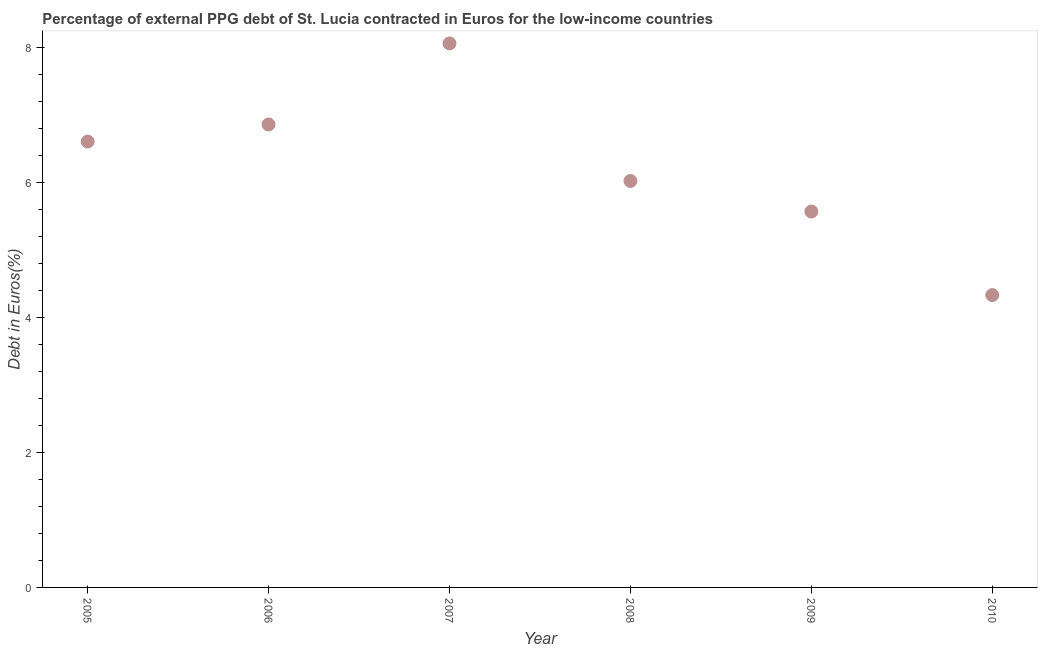What is the currency composition of ppg debt in 2006?
Offer a very short reply. 6.86. Across all years, what is the maximum currency composition of ppg debt?
Provide a short and direct response. 8.07. Across all years, what is the minimum currency composition of ppg debt?
Give a very brief answer. 4.33. What is the sum of the currency composition of ppg debt?
Provide a succinct answer. 37.48. What is the difference between the currency composition of ppg debt in 2005 and 2006?
Offer a terse response. -0.25. What is the average currency composition of ppg debt per year?
Your response must be concise. 6.25. What is the median currency composition of ppg debt?
Make the answer very short. 6.32. In how many years, is the currency composition of ppg debt greater than 2.8 %?
Provide a short and direct response. 6. What is the ratio of the currency composition of ppg debt in 2005 to that in 2010?
Provide a short and direct response. 1.53. Is the difference between the currency composition of ppg debt in 2007 and 2008 greater than the difference between any two years?
Provide a short and direct response. No. What is the difference between the highest and the second highest currency composition of ppg debt?
Your answer should be very brief. 1.2. Is the sum of the currency composition of ppg debt in 2005 and 2010 greater than the maximum currency composition of ppg debt across all years?
Keep it short and to the point. Yes. What is the difference between the highest and the lowest currency composition of ppg debt?
Make the answer very short. 3.73. How many dotlines are there?
Keep it short and to the point. 1. How many years are there in the graph?
Give a very brief answer. 6. Are the values on the major ticks of Y-axis written in scientific E-notation?
Make the answer very short. No. Does the graph contain any zero values?
Your response must be concise. No. What is the title of the graph?
Make the answer very short. Percentage of external PPG debt of St. Lucia contracted in Euros for the low-income countries. What is the label or title of the X-axis?
Make the answer very short. Year. What is the label or title of the Y-axis?
Your answer should be very brief. Debt in Euros(%). What is the Debt in Euros(%) in 2005?
Offer a terse response. 6.61. What is the Debt in Euros(%) in 2006?
Provide a succinct answer. 6.86. What is the Debt in Euros(%) in 2007?
Make the answer very short. 8.07. What is the Debt in Euros(%) in 2008?
Ensure brevity in your answer.  6.03. What is the Debt in Euros(%) in 2009?
Give a very brief answer. 5.57. What is the Debt in Euros(%) in 2010?
Ensure brevity in your answer.  4.33. What is the difference between the Debt in Euros(%) in 2005 and 2006?
Offer a terse response. -0.25. What is the difference between the Debt in Euros(%) in 2005 and 2007?
Your answer should be very brief. -1.46. What is the difference between the Debt in Euros(%) in 2005 and 2008?
Provide a succinct answer. 0.58. What is the difference between the Debt in Euros(%) in 2005 and 2009?
Your answer should be compact. 1.04. What is the difference between the Debt in Euros(%) in 2005 and 2010?
Offer a terse response. 2.28. What is the difference between the Debt in Euros(%) in 2006 and 2007?
Provide a short and direct response. -1.2. What is the difference between the Debt in Euros(%) in 2006 and 2008?
Your answer should be very brief. 0.84. What is the difference between the Debt in Euros(%) in 2006 and 2009?
Your response must be concise. 1.29. What is the difference between the Debt in Euros(%) in 2006 and 2010?
Ensure brevity in your answer.  2.53. What is the difference between the Debt in Euros(%) in 2007 and 2008?
Keep it short and to the point. 2.04. What is the difference between the Debt in Euros(%) in 2007 and 2009?
Your response must be concise. 2.49. What is the difference between the Debt in Euros(%) in 2007 and 2010?
Provide a succinct answer. 3.73. What is the difference between the Debt in Euros(%) in 2008 and 2009?
Provide a succinct answer. 0.45. What is the difference between the Debt in Euros(%) in 2008 and 2010?
Ensure brevity in your answer.  1.69. What is the difference between the Debt in Euros(%) in 2009 and 2010?
Provide a succinct answer. 1.24. What is the ratio of the Debt in Euros(%) in 2005 to that in 2006?
Your answer should be compact. 0.96. What is the ratio of the Debt in Euros(%) in 2005 to that in 2007?
Your answer should be compact. 0.82. What is the ratio of the Debt in Euros(%) in 2005 to that in 2008?
Keep it short and to the point. 1.1. What is the ratio of the Debt in Euros(%) in 2005 to that in 2009?
Keep it short and to the point. 1.19. What is the ratio of the Debt in Euros(%) in 2005 to that in 2010?
Your answer should be compact. 1.52. What is the ratio of the Debt in Euros(%) in 2006 to that in 2007?
Make the answer very short. 0.85. What is the ratio of the Debt in Euros(%) in 2006 to that in 2008?
Offer a terse response. 1.14. What is the ratio of the Debt in Euros(%) in 2006 to that in 2009?
Give a very brief answer. 1.23. What is the ratio of the Debt in Euros(%) in 2006 to that in 2010?
Your response must be concise. 1.58. What is the ratio of the Debt in Euros(%) in 2007 to that in 2008?
Ensure brevity in your answer.  1.34. What is the ratio of the Debt in Euros(%) in 2007 to that in 2009?
Provide a short and direct response. 1.45. What is the ratio of the Debt in Euros(%) in 2007 to that in 2010?
Offer a terse response. 1.86. What is the ratio of the Debt in Euros(%) in 2008 to that in 2009?
Offer a terse response. 1.08. What is the ratio of the Debt in Euros(%) in 2008 to that in 2010?
Your answer should be very brief. 1.39. What is the ratio of the Debt in Euros(%) in 2009 to that in 2010?
Provide a short and direct response. 1.29. 